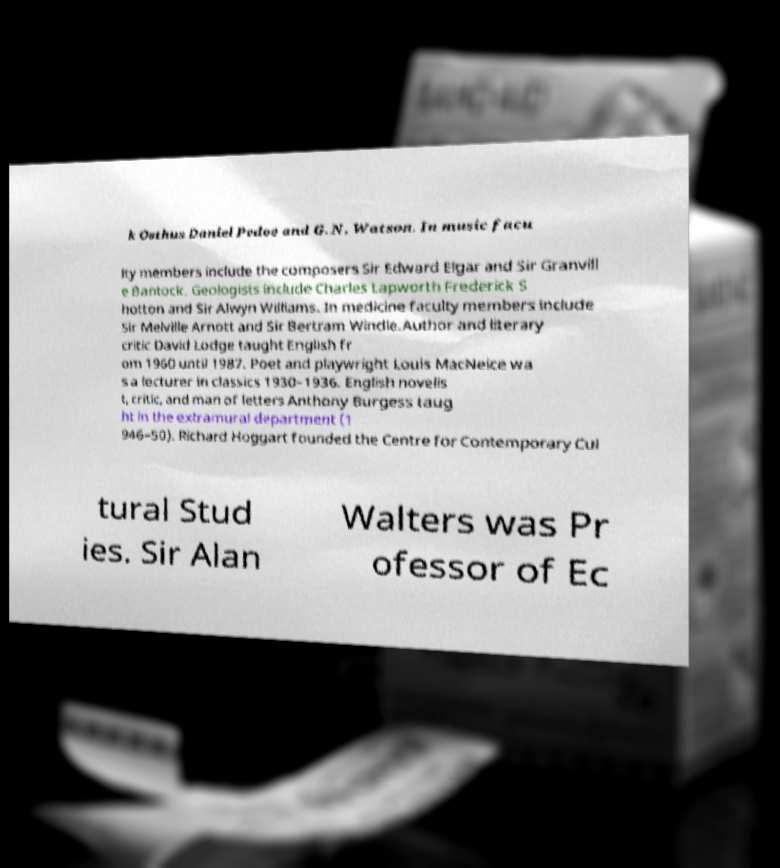What messages or text are displayed in this image? I need them in a readable, typed format. k Osthus Daniel Pedoe and G. N. Watson. In music facu lty members include the composers Sir Edward Elgar and Sir Granvill e Bantock. Geologists include Charles Lapworth Frederick S hotton and Sir Alwyn Williams. In medicine faculty members include Sir Melville Arnott and Sir Bertram Windle.Author and literary critic David Lodge taught English fr om 1960 until 1987. Poet and playwright Louis MacNeice wa s a lecturer in classics 1930–1936. English novelis t, critic, and man of letters Anthony Burgess taug ht in the extramural department (1 946–50). Richard Hoggart founded the Centre for Contemporary Cul tural Stud ies. Sir Alan Walters was Pr ofessor of Ec 